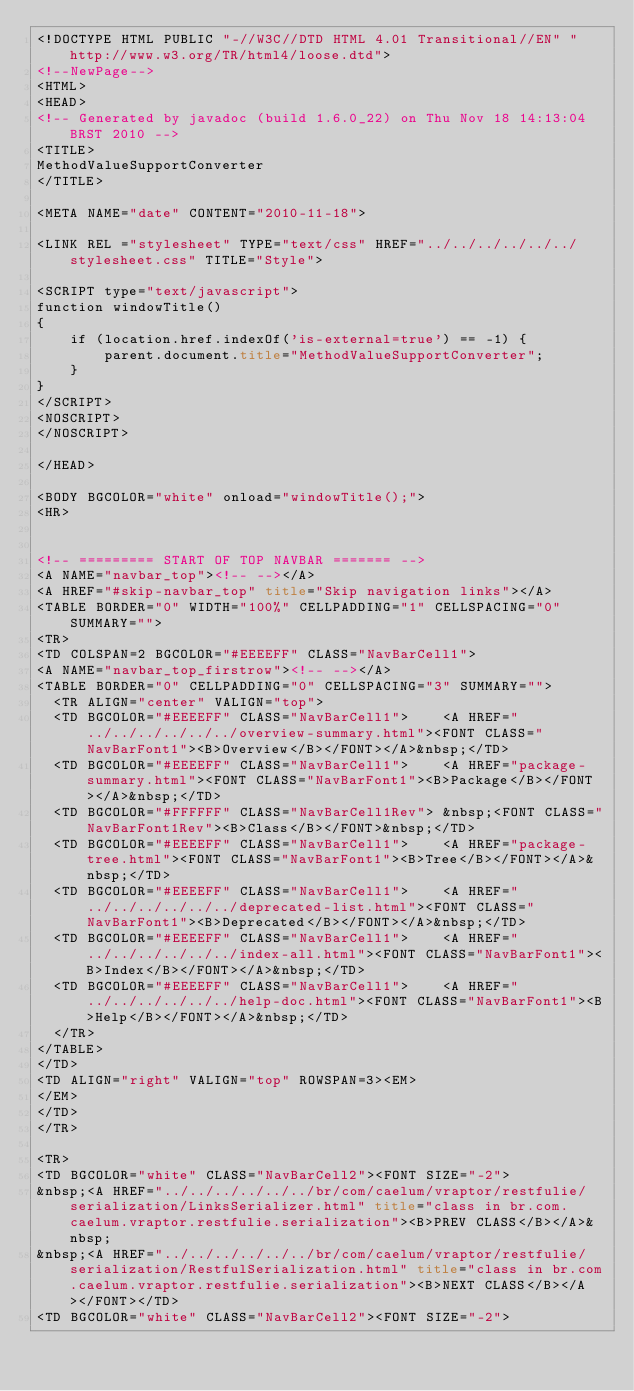Convert code to text. <code><loc_0><loc_0><loc_500><loc_500><_HTML_><!DOCTYPE HTML PUBLIC "-//W3C//DTD HTML 4.01 Transitional//EN" "http://www.w3.org/TR/html4/loose.dtd">
<!--NewPage-->
<HTML>
<HEAD>
<!-- Generated by javadoc (build 1.6.0_22) on Thu Nov 18 14:13:04 BRST 2010 -->
<TITLE>
MethodValueSupportConverter
</TITLE>

<META NAME="date" CONTENT="2010-11-18">

<LINK REL ="stylesheet" TYPE="text/css" HREF="../../../../../../stylesheet.css" TITLE="Style">

<SCRIPT type="text/javascript">
function windowTitle()
{
    if (location.href.indexOf('is-external=true') == -1) {
        parent.document.title="MethodValueSupportConverter";
    }
}
</SCRIPT>
<NOSCRIPT>
</NOSCRIPT>

</HEAD>

<BODY BGCOLOR="white" onload="windowTitle();">
<HR>


<!-- ========= START OF TOP NAVBAR ======= -->
<A NAME="navbar_top"><!-- --></A>
<A HREF="#skip-navbar_top" title="Skip navigation links"></A>
<TABLE BORDER="0" WIDTH="100%" CELLPADDING="1" CELLSPACING="0" SUMMARY="">
<TR>
<TD COLSPAN=2 BGCOLOR="#EEEEFF" CLASS="NavBarCell1">
<A NAME="navbar_top_firstrow"><!-- --></A>
<TABLE BORDER="0" CELLPADDING="0" CELLSPACING="3" SUMMARY="">
  <TR ALIGN="center" VALIGN="top">
  <TD BGCOLOR="#EEEEFF" CLASS="NavBarCell1">    <A HREF="../../../../../../overview-summary.html"><FONT CLASS="NavBarFont1"><B>Overview</B></FONT></A>&nbsp;</TD>
  <TD BGCOLOR="#EEEEFF" CLASS="NavBarCell1">    <A HREF="package-summary.html"><FONT CLASS="NavBarFont1"><B>Package</B></FONT></A>&nbsp;</TD>
  <TD BGCOLOR="#FFFFFF" CLASS="NavBarCell1Rev"> &nbsp;<FONT CLASS="NavBarFont1Rev"><B>Class</B></FONT>&nbsp;</TD>
  <TD BGCOLOR="#EEEEFF" CLASS="NavBarCell1">    <A HREF="package-tree.html"><FONT CLASS="NavBarFont1"><B>Tree</B></FONT></A>&nbsp;</TD>
  <TD BGCOLOR="#EEEEFF" CLASS="NavBarCell1">    <A HREF="../../../../../../deprecated-list.html"><FONT CLASS="NavBarFont1"><B>Deprecated</B></FONT></A>&nbsp;</TD>
  <TD BGCOLOR="#EEEEFF" CLASS="NavBarCell1">    <A HREF="../../../../../../index-all.html"><FONT CLASS="NavBarFont1"><B>Index</B></FONT></A>&nbsp;</TD>
  <TD BGCOLOR="#EEEEFF" CLASS="NavBarCell1">    <A HREF="../../../../../../help-doc.html"><FONT CLASS="NavBarFont1"><B>Help</B></FONT></A>&nbsp;</TD>
  </TR>
</TABLE>
</TD>
<TD ALIGN="right" VALIGN="top" ROWSPAN=3><EM>
</EM>
</TD>
</TR>

<TR>
<TD BGCOLOR="white" CLASS="NavBarCell2"><FONT SIZE="-2">
&nbsp;<A HREF="../../../../../../br/com/caelum/vraptor/restfulie/serialization/LinksSerializer.html" title="class in br.com.caelum.vraptor.restfulie.serialization"><B>PREV CLASS</B></A>&nbsp;
&nbsp;<A HREF="../../../../../../br/com/caelum/vraptor/restfulie/serialization/RestfulSerialization.html" title="class in br.com.caelum.vraptor.restfulie.serialization"><B>NEXT CLASS</B></A></FONT></TD>
<TD BGCOLOR="white" CLASS="NavBarCell2"><FONT SIZE="-2"></code> 